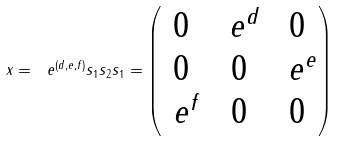<formula> <loc_0><loc_0><loc_500><loc_500>x = \ e ^ { ( d , e , f ) } s _ { 1 } s _ { 2 } s _ { 1 } = \begin{pmatrix} 0 & \ e ^ { d } & 0 \\ 0 & 0 & \ e ^ { e } \\ \ e ^ { f } & 0 & 0 \end{pmatrix}</formula> 